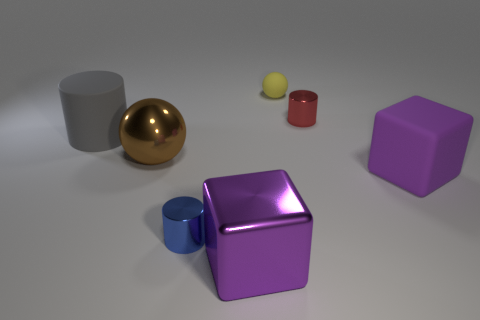Is the shape of the purple shiny object the same as the tiny blue object?
Make the answer very short. No. What number of things are big matte things that are to the right of the small blue thing or matte objects in front of the large brown metallic thing?
Offer a terse response. 1. How many things are small cyan metallic spheres or big brown metallic objects?
Provide a succinct answer. 1. What number of things are in front of the matte cube that is on the right side of the big gray rubber cylinder?
Provide a succinct answer. 2. How many other things are the same size as the purple rubber block?
Your answer should be very brief. 3. There is a thing that is the same color as the large rubber block; what size is it?
Your response must be concise. Large. Is the shape of the small metal object that is behind the big gray cylinder the same as  the tiny rubber thing?
Your answer should be compact. No. There is a cylinder that is right of the purple shiny thing; what material is it?
Provide a succinct answer. Metal. What shape is the large object that is the same color as the rubber block?
Ensure brevity in your answer.  Cube. Are there any purple things that have the same material as the yellow ball?
Your answer should be very brief. Yes. 